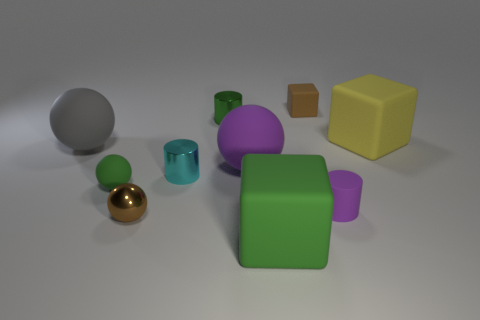Subtract all small rubber blocks. How many blocks are left? 2 Subtract 1 cubes. How many cubes are left? 2 Subtract all green spheres. How many spheres are left? 3 Subtract all cylinders. How many objects are left? 7 Subtract all blue balls. Subtract all blue cylinders. How many balls are left? 4 Subtract all tiny green metallic balls. Subtract all small green matte things. How many objects are left? 9 Add 5 large green matte blocks. How many large green matte blocks are left? 6 Add 2 tiny purple metallic cylinders. How many tiny purple metallic cylinders exist? 2 Subtract 0 cyan blocks. How many objects are left? 10 